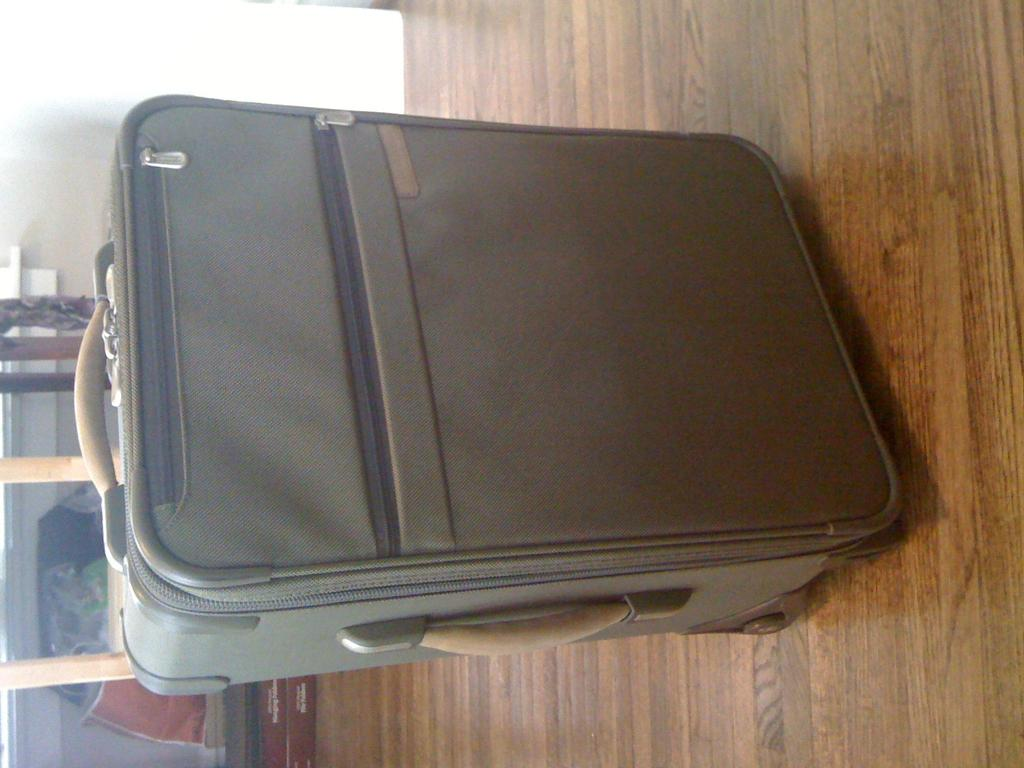What is the color of the trolley in the image? The trolley in the image is light green. What features does the trolley have? The trolley has zips and a holder. What can be seen in the background of the image? There is a table in the background of the image. Can you tell me how many women are teaching the kitten in the image? There are no women or kittens present in the image; it features a light green trolley with zips and a holder, and a table in the background. 